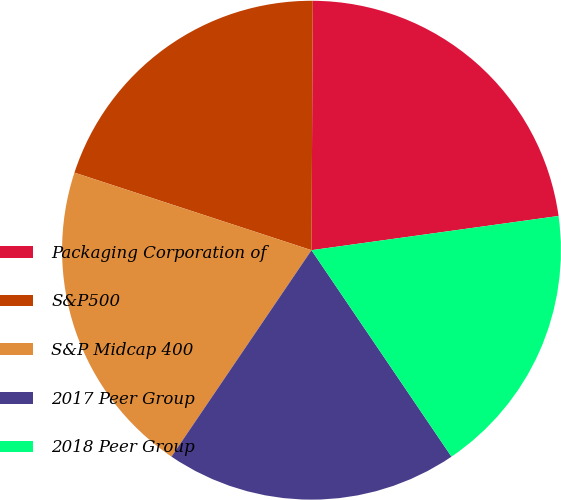Convert chart to OTSL. <chart><loc_0><loc_0><loc_500><loc_500><pie_chart><fcel>Packaging Corporation of<fcel>S&P500<fcel>S&P Midcap 400<fcel>2017 Peer Group<fcel>2018 Peer Group<nl><fcel>22.73%<fcel>20.05%<fcel>20.55%<fcel>18.97%<fcel>17.71%<nl></chart> 